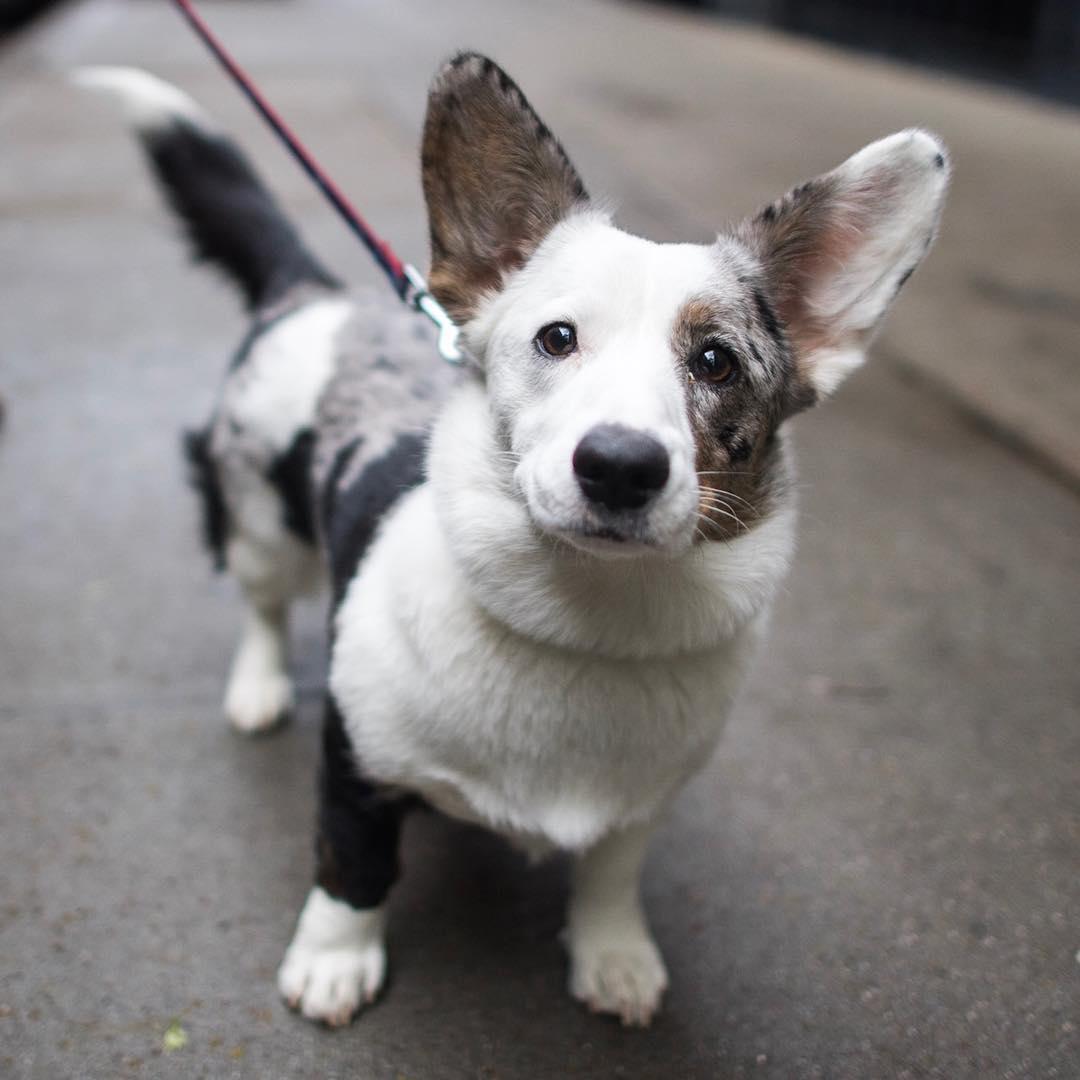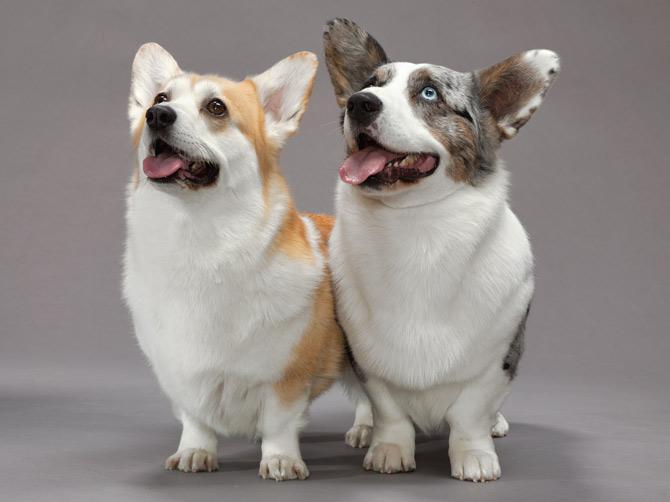The first image is the image on the left, the second image is the image on the right. For the images shown, is this caption "There are four dogs in the image pair." true? Answer yes or no. No. The first image is the image on the left, the second image is the image on the right. Assess this claim about the two images: "The left image contains exactly two dogs.". Correct or not? Answer yes or no. No. 